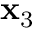<formula> <loc_0><loc_0><loc_500><loc_500>x _ { 3 }</formula> 